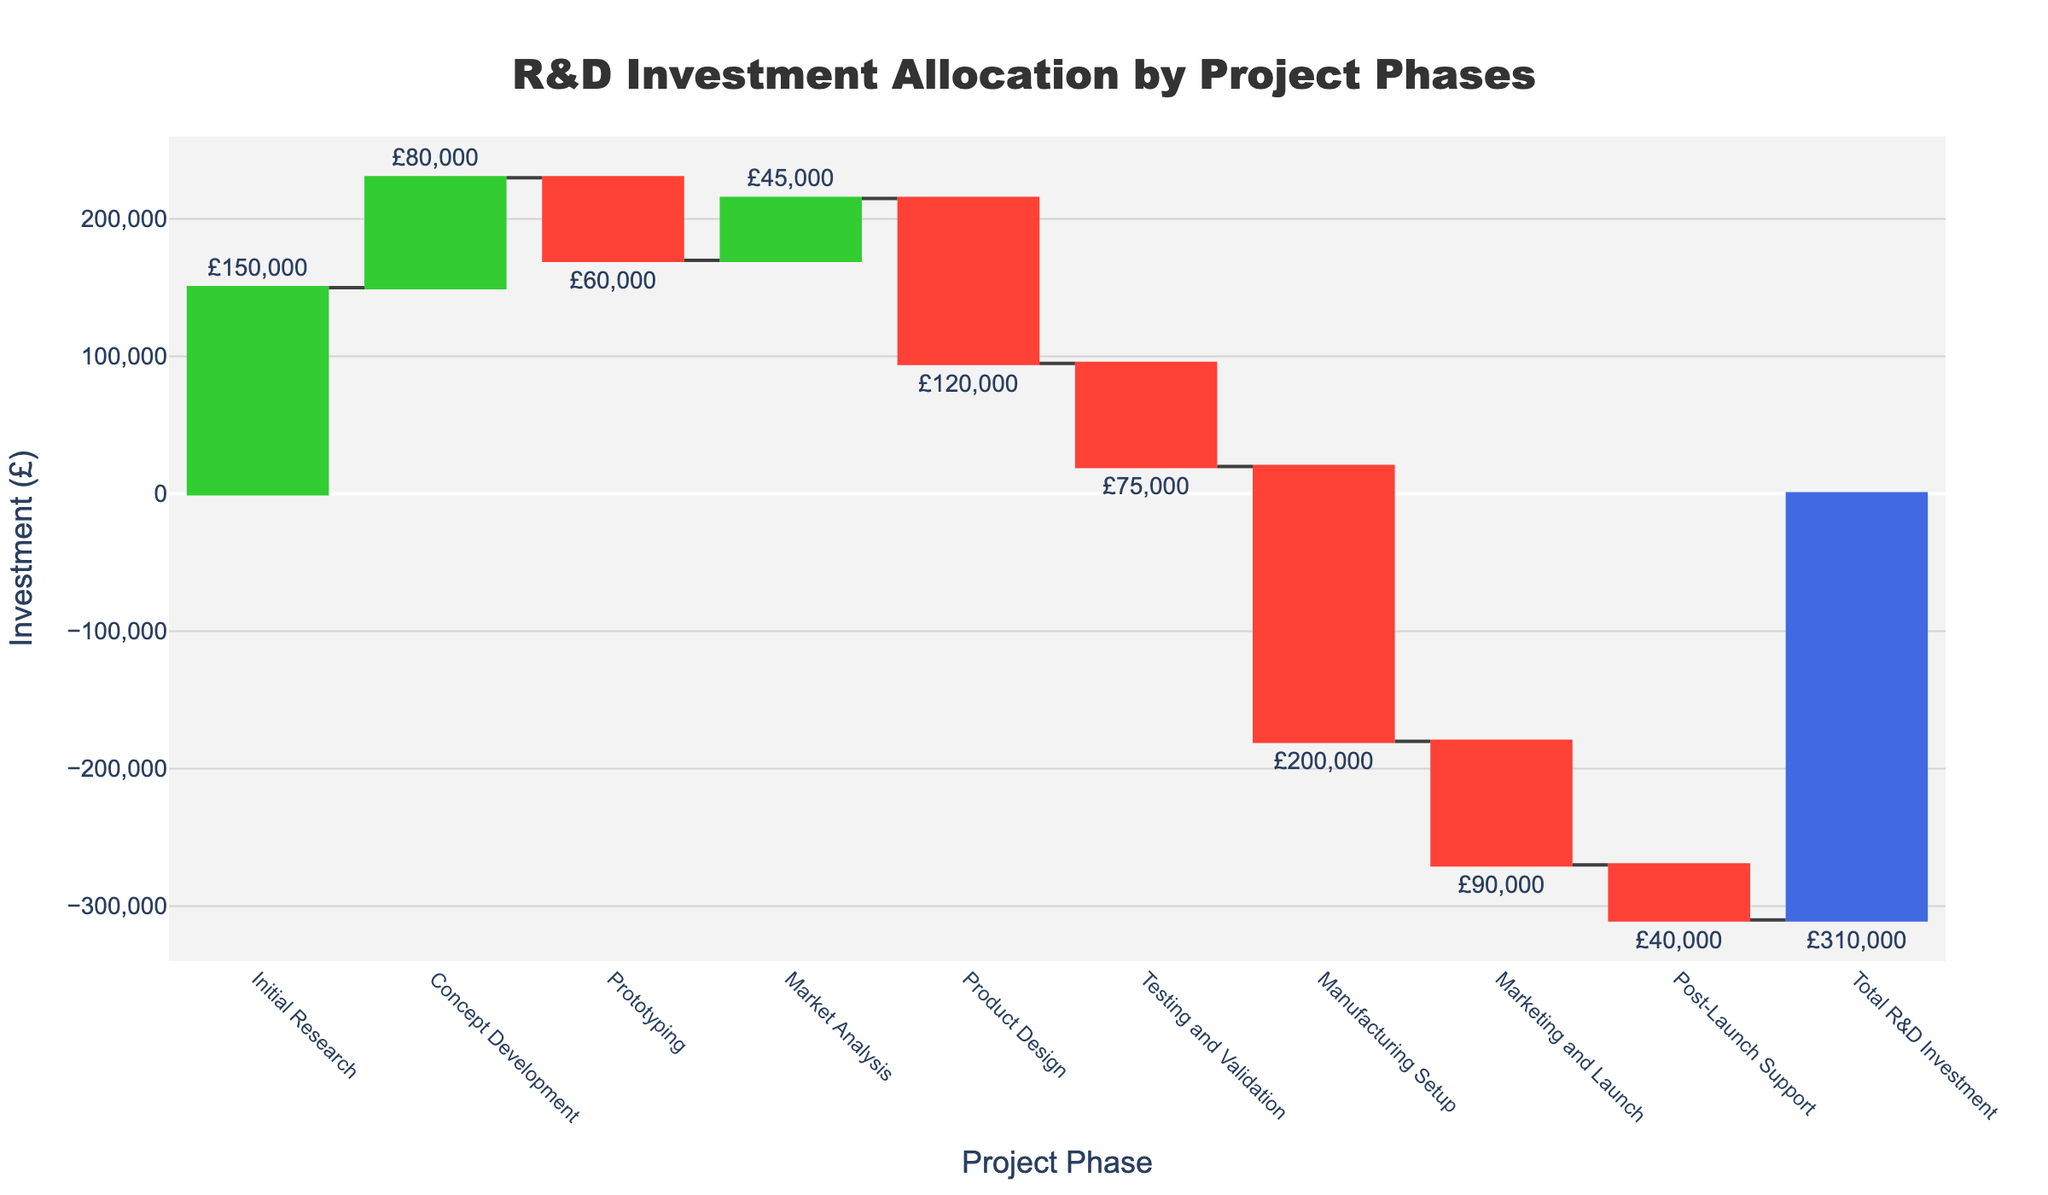What's the title of the chart? The title is displayed at the top and centered. It provides an overview of what the chart is depicting. In this case, it reads "R&D Investment Allocation by Project Phases."
Answer: R&D Investment Allocation by Project Phases How much was invested in the Initial Research phase? The figure lists each project phase along with its corresponding investment. For Initial Research, it shows an investment of £150,000.
Answer: £150,000 Which phase had the largest negative investment? The waterfall chart uses different colors to indicate positive and negative investments. The biggest negative value will have the longest red bar. In this case, the Manufacturing Setup phase has the largest negative investment of £200,000.
Answer: Manufacturing Setup What is the total R&D investment across all phases? The total R&D investment is highlighted at the end of the chart, usually in a distinct color. It sums up all the investments and shows a value of -£310,000.
Answer: -£310,000 Which phases incurred a cost reduction? Costs reductions will be represented by red bars in the waterfall chart. The phases with negative values include Prototyping, Product Design, Testing and Validation, Manufacturing Setup, Marketing and Launch, and Post-Launch Support.
Answer: Prototyping, Product Design, Testing and Validation, Manufacturing Setup, Marketing and Launch, Post-Launch Support What would the investment be after the Prototyping phase? To find this, you sum the values from the Initial Research, Concept Development, and Prototyping phases. Initial Research + Concept Development + Prototyping = £150,000 + £80,000 - £60,000 = £170,000.
Answer: £170,000 How does the investment in Market Analysis compare to the investment in Prototyping? Comparing the Market Analysis and Prototyping phases, Market Analysis had a positive investment of £45,000 while Prototyping had a negative investment of £60,000.
Answer: Market Analysis had a higher investment Which phase immediately follows Market Analysis? Looking at the sequence of phases in the chart, Product Design comes right after Market Analysis.
Answer: Product Design Sum the investments from Initial Research, Concept Development, and Market Analysis phases. You add the investments from these three phases: £150,000 (Initial Research) + £80,000 (Concept Development) + £45,000 (Market Analysis) = £275,000.
Answer: £275,000 What color represents the final total R&D investment in the chart? The final total is typically distinguished in a unique color. In this case, it is represented in a blue shade.
Answer: Blue 